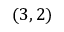Convert formula to latex. <formula><loc_0><loc_0><loc_500><loc_500>( 3 , 2 )</formula> 